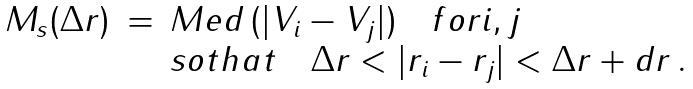<formula> <loc_0><loc_0><loc_500><loc_500>\begin{array} { l c l } M _ { s } ( \Delta r ) & = & M e d \, ( | V _ { i } - V _ { j } | ) \quad f o r i , j \\ & & s o t h a t \quad \Delta r < | r _ { i } - r _ { j } | < \Delta r + d r \, . \end{array}</formula> 